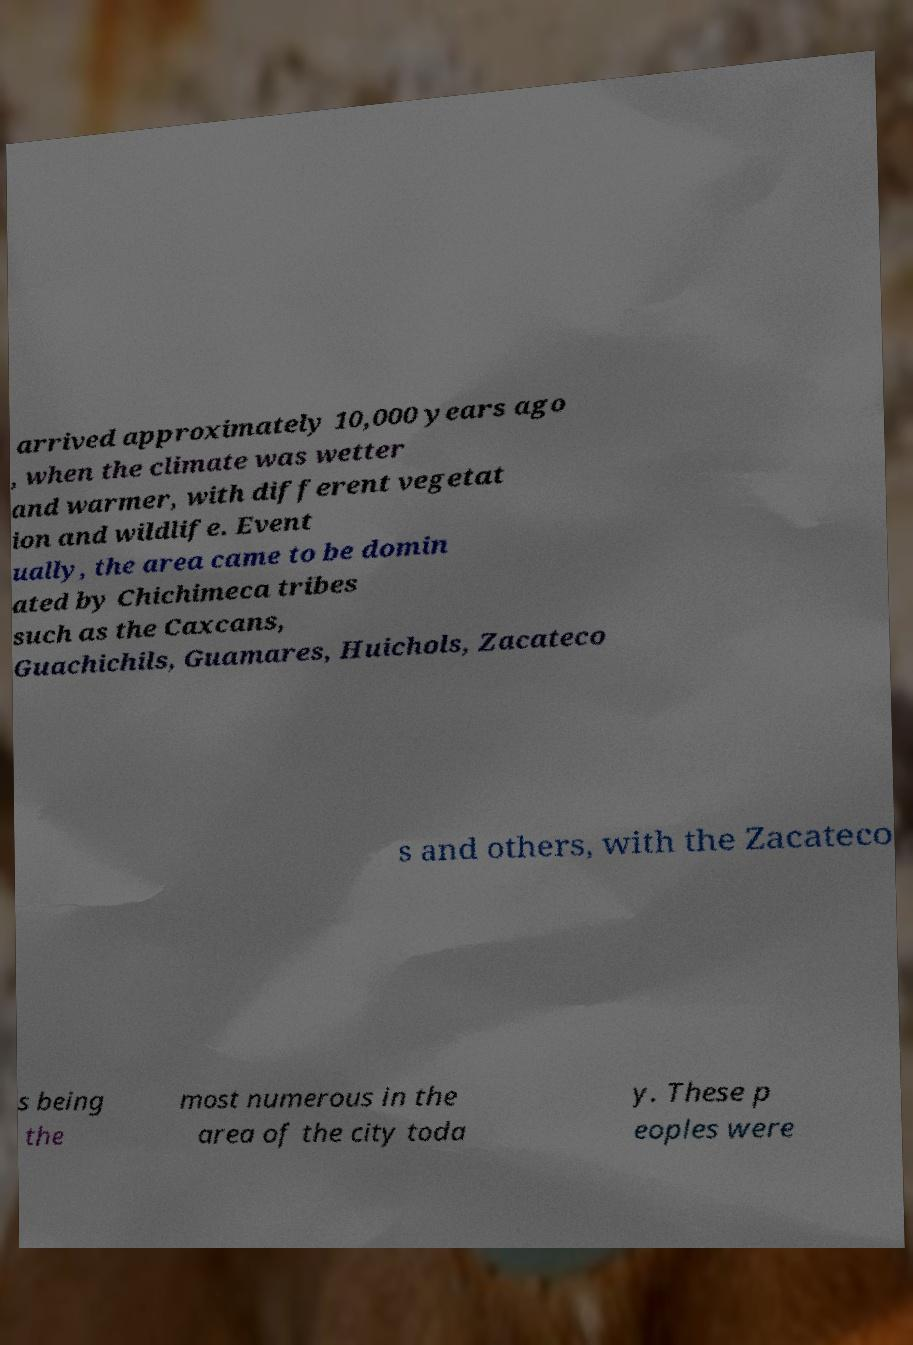I need the written content from this picture converted into text. Can you do that? arrived approximately 10,000 years ago , when the climate was wetter and warmer, with different vegetat ion and wildlife. Event ually, the area came to be domin ated by Chichimeca tribes such as the Caxcans, Guachichils, Guamares, Huichols, Zacateco s and others, with the Zacateco s being the most numerous in the area of the city toda y. These p eoples were 